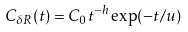Convert formula to latex. <formula><loc_0><loc_0><loc_500><loc_500>C _ { \delta R } ( t ) = C _ { 0 } t ^ { - h } \exp ( - t / u )</formula> 